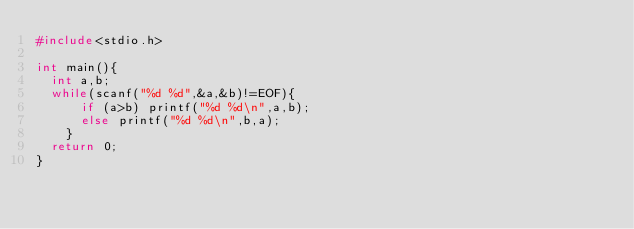<code> <loc_0><loc_0><loc_500><loc_500><_C_>#include<stdio.h>

int main(){
  int a,b;
  while(scanf("%d %d",&a,&b)!=EOF){
      if (a>b) printf("%d %d\n",a,b);
      else printf("%d %d\n",b,a);
    }
  return 0;
}</code> 